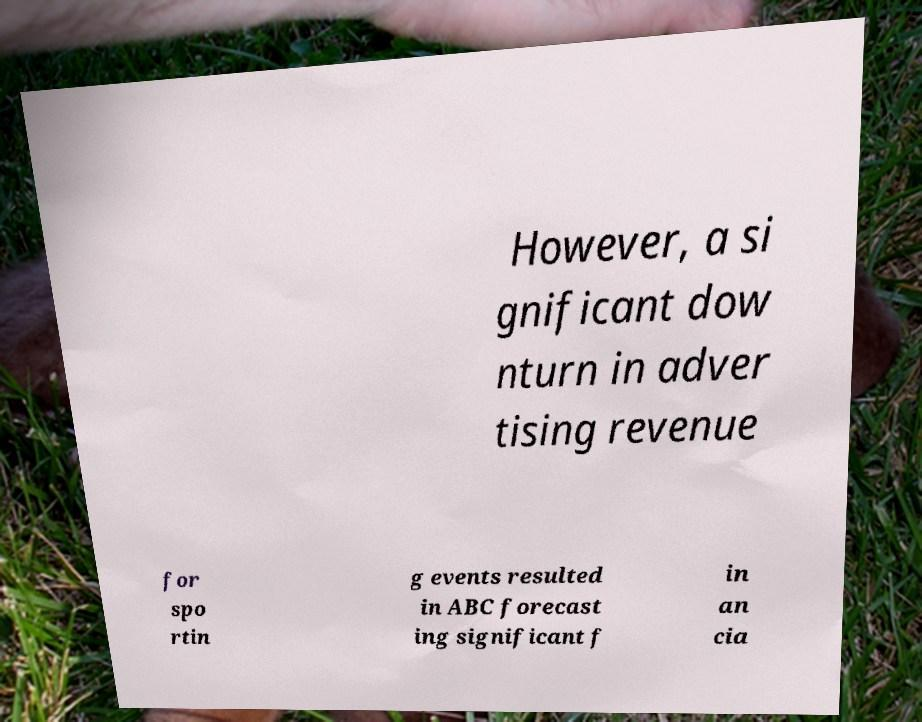There's text embedded in this image that I need extracted. Can you transcribe it verbatim? However, a si gnificant dow nturn in adver tising revenue for spo rtin g events resulted in ABC forecast ing significant f in an cia 